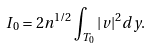Convert formula to latex. <formula><loc_0><loc_0><loc_500><loc_500>I _ { 0 } = 2 n ^ { 1 / 2 } \int _ { T _ { 0 } } | v | ^ { 2 } d y .</formula> 